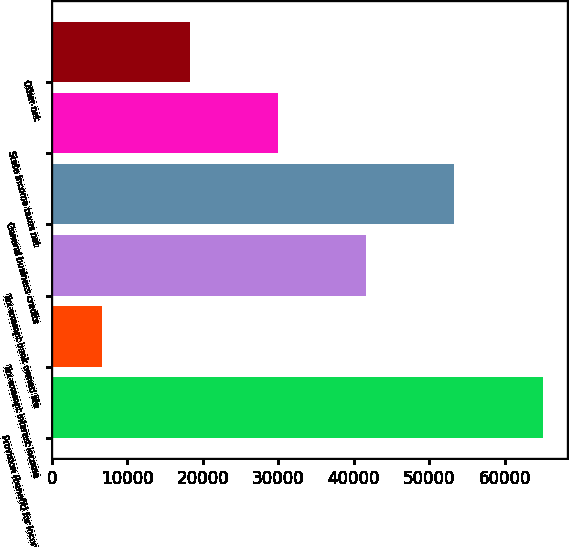Convert chart. <chart><loc_0><loc_0><loc_500><loc_500><bar_chart><fcel>Provision (benefit) for income<fcel>Tax-exempt interest income<fcel>Tax-exempt bank owned life<fcel>General business credits<fcel>State income taxes net<fcel>Other net<nl><fcel>64995<fcel>6680<fcel>41669<fcel>53332<fcel>30006<fcel>18343<nl></chart> 